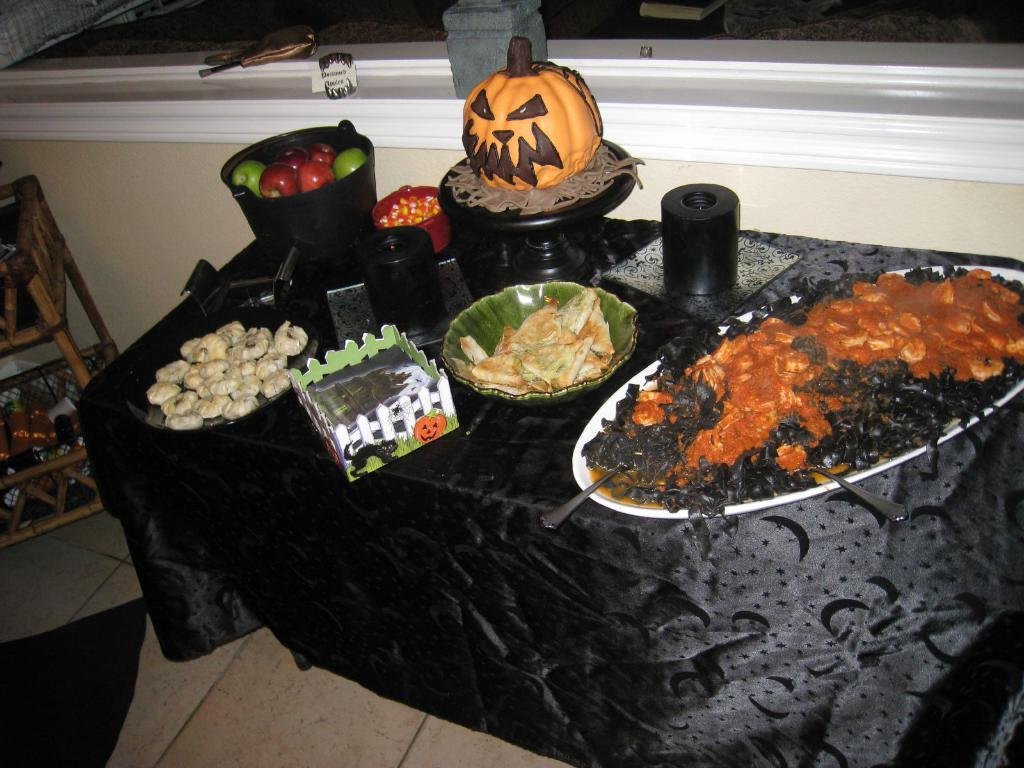What piece of furniture is present in the image? There is a table in the image. What is located on the table in the image? There is a serving table with different kinds of foods in the image. What type of food can be seen in the basket in the image? There is a basket full of fruits in the image. What type of cactus is growing on the table in the image? There is no cactus present in the image; the table has a serving table with different kinds of foods and a basket full of fruits. 